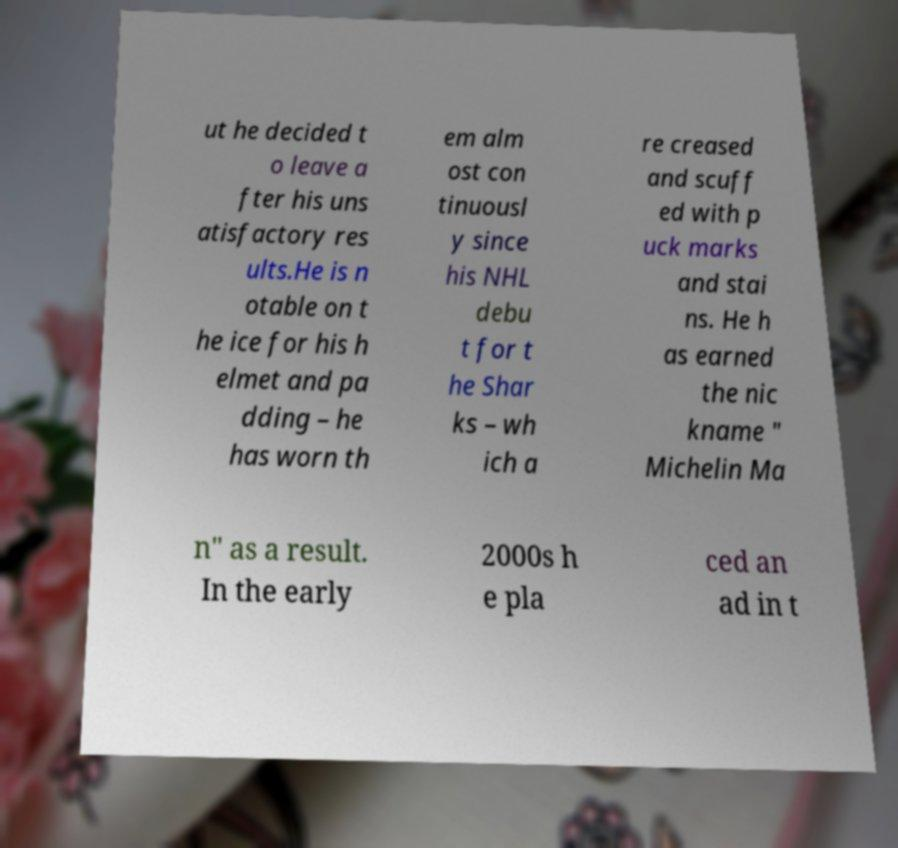For documentation purposes, I need the text within this image transcribed. Could you provide that? ut he decided t o leave a fter his uns atisfactory res ults.He is n otable on t he ice for his h elmet and pa dding – he has worn th em alm ost con tinuousl y since his NHL debu t for t he Shar ks – wh ich a re creased and scuff ed with p uck marks and stai ns. He h as earned the nic kname " Michelin Ma n" as a result. In the early 2000s h e pla ced an ad in t 